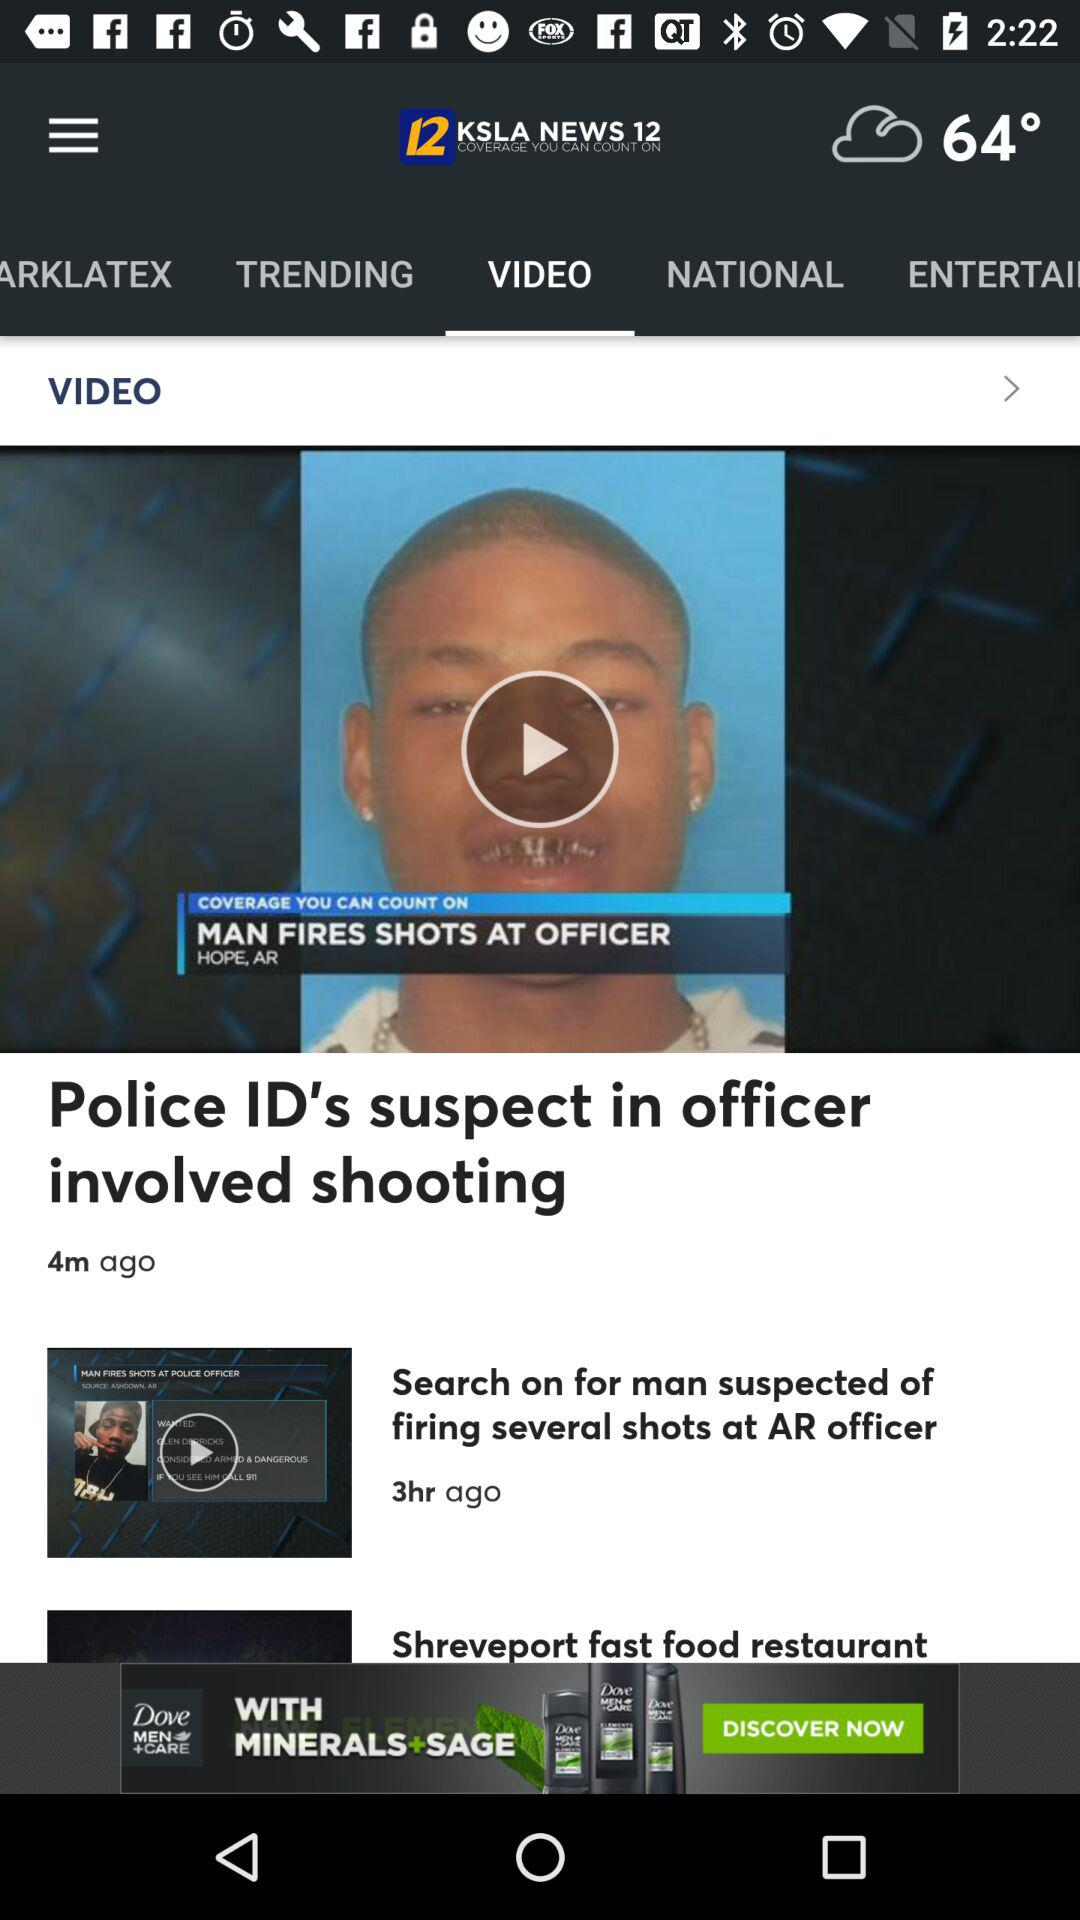How long ago was the video "Police ID's suspect in officer involved shooting" posted? The video was posted 4 minutes ago. 